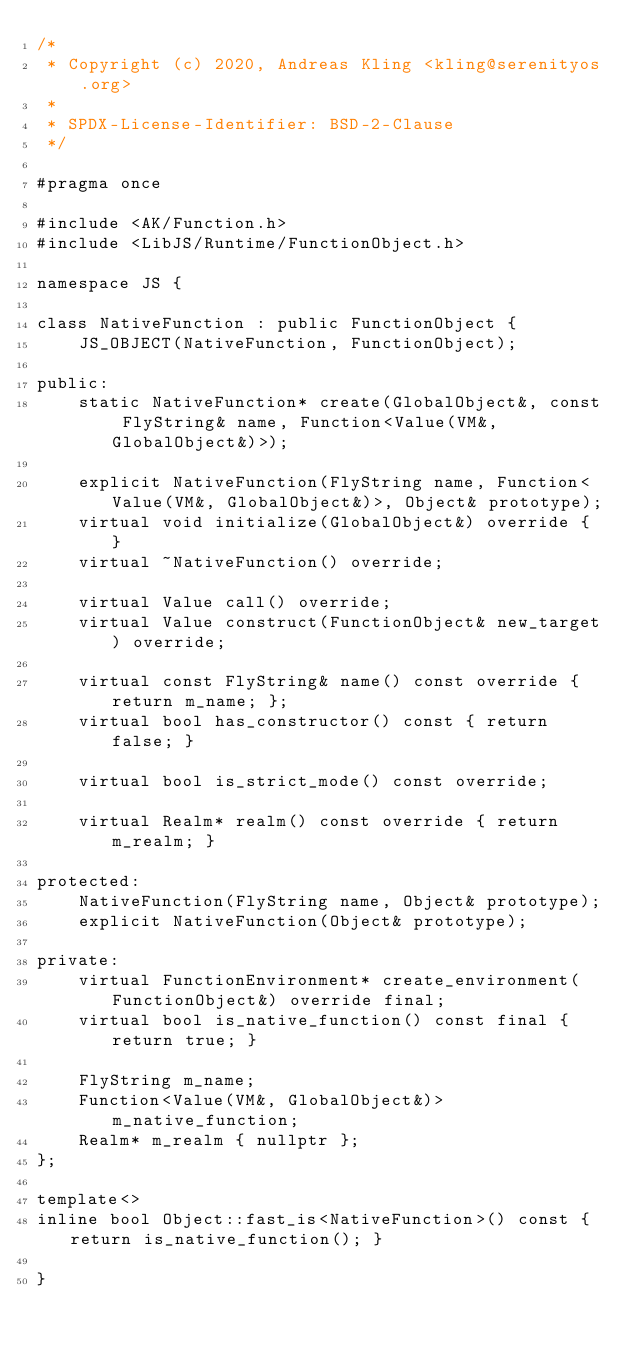Convert code to text. <code><loc_0><loc_0><loc_500><loc_500><_C_>/*
 * Copyright (c) 2020, Andreas Kling <kling@serenityos.org>
 *
 * SPDX-License-Identifier: BSD-2-Clause
 */

#pragma once

#include <AK/Function.h>
#include <LibJS/Runtime/FunctionObject.h>

namespace JS {

class NativeFunction : public FunctionObject {
    JS_OBJECT(NativeFunction, FunctionObject);

public:
    static NativeFunction* create(GlobalObject&, const FlyString& name, Function<Value(VM&, GlobalObject&)>);

    explicit NativeFunction(FlyString name, Function<Value(VM&, GlobalObject&)>, Object& prototype);
    virtual void initialize(GlobalObject&) override { }
    virtual ~NativeFunction() override;

    virtual Value call() override;
    virtual Value construct(FunctionObject& new_target) override;

    virtual const FlyString& name() const override { return m_name; };
    virtual bool has_constructor() const { return false; }

    virtual bool is_strict_mode() const override;

    virtual Realm* realm() const override { return m_realm; }

protected:
    NativeFunction(FlyString name, Object& prototype);
    explicit NativeFunction(Object& prototype);

private:
    virtual FunctionEnvironment* create_environment(FunctionObject&) override final;
    virtual bool is_native_function() const final { return true; }

    FlyString m_name;
    Function<Value(VM&, GlobalObject&)> m_native_function;
    Realm* m_realm { nullptr };
};

template<>
inline bool Object::fast_is<NativeFunction>() const { return is_native_function(); }

}
</code> 